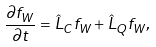Convert formula to latex. <formula><loc_0><loc_0><loc_500><loc_500>\frac { \partial f _ { W } } { \partial t } = \hat { L } _ { C } f _ { W } + \hat { L } _ { Q } f _ { W } ,</formula> 